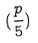Convert formula to latex. <formula><loc_0><loc_0><loc_500><loc_500>( \frac { p } { 5 } )</formula> 